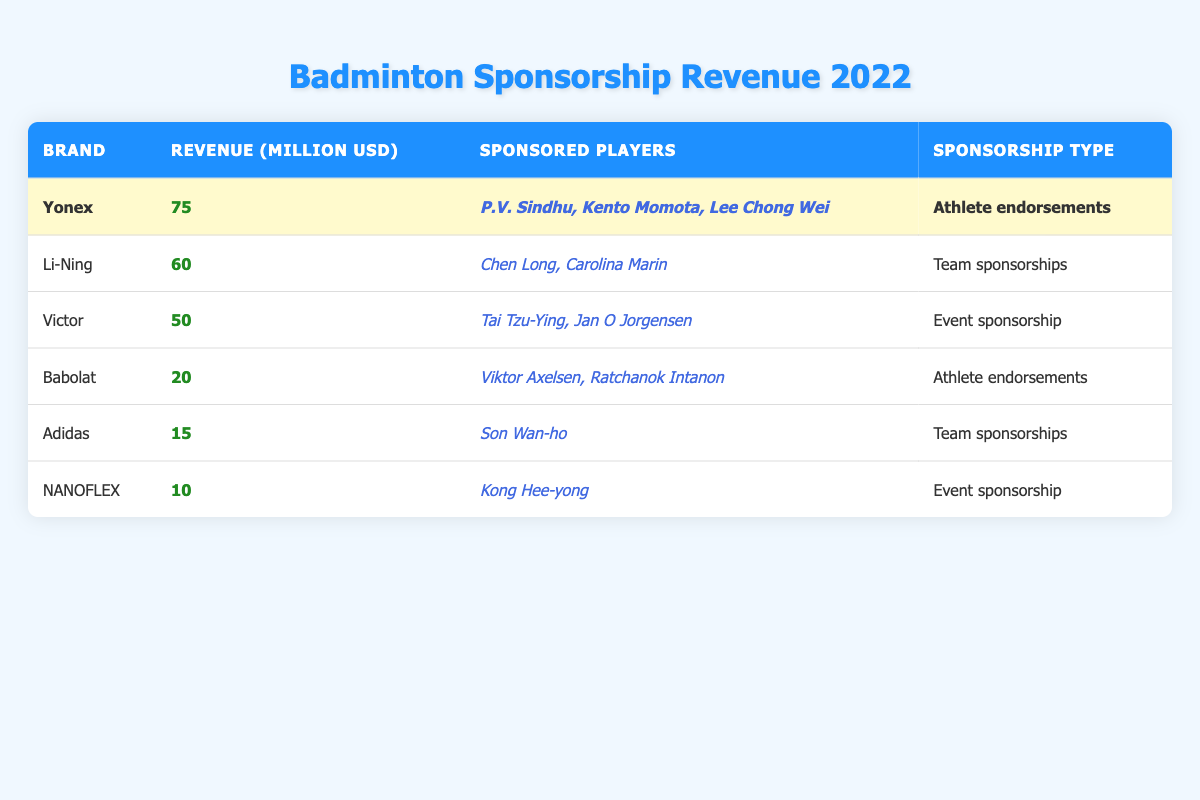What is the highest sponsorship revenue among the brands? By reviewing the table, Yonex has the highest revenue listed at 75 million USD, which is more than any other brand.
Answer: 75 million USD Which brand has sponsored the most players? Looking at the table, Yonex sponsored three players: P.V. Sindhu, Kento Momota, and Lee Chong Wei. Other brands have sponsored fewer players.
Answer: Yonex What is the total sponsorship revenue from Babolat and Adidas combined? Adding the revenues of Babolat (20 million USD) and Adidas (15 million USD) gives 20 + 15 = 35 million USD.
Answer: 35 million USD Is Victor's sponsorship type an athlete endorsement? The table indicates that Victor's sponsorship type is "Event sponsorship," not "Athlete endorsements," making the statement false.
Answer: No What percentage of the total sponsorship revenue does Li-Ning contribute? The total revenue from all brands is 75 + 60 + 50 + 20 + 15 + 10 = 230 million USD. Li-Ning contributes 60 million USD, which is (60/230) * 100 = 26.09%.
Answer: 26.09% Which brand has the least sponsorship revenue, and what is that amount? Reviewing the table, NANOFLEX shows the lowest revenue at 10 million USD, making it the brand with the least sponsorship revenue.
Answer: NANOFLEX, 10 million USD How much more revenue does Yonex have compared to Babolat? The revenue for Yonex is 75 million USD, and for Babolat, it is 20 million USD. The difference is 75 - 20 = 55 million USD.
Answer: 55 million USD Did any brand focus solely on athlete endorsements for sponsorship? The table shows Babolat and Yonex engaged in athlete endorsements, while the others have different sponsorship types, confirming that there are brands focusing solely on athlete endorsements.
Answer: Yes What is the average revenue among the brands listed in the table? To find the average, sum the revenues (75 + 60 + 50 + 20 + 15 + 10 = 230 million USD) and divide by the number of brands (6). So, the average is 230 / 6 ≈ 38.33 million USD.
Answer: 38.33 million USD Which player sponsored by Yonex is a prominent name in women's badminton? P.V. Sindhu is a well-known female player sponsored by Yonex, making her the prominent name in women's badminton among the players listed.
Answer: P.V. Sindhu 